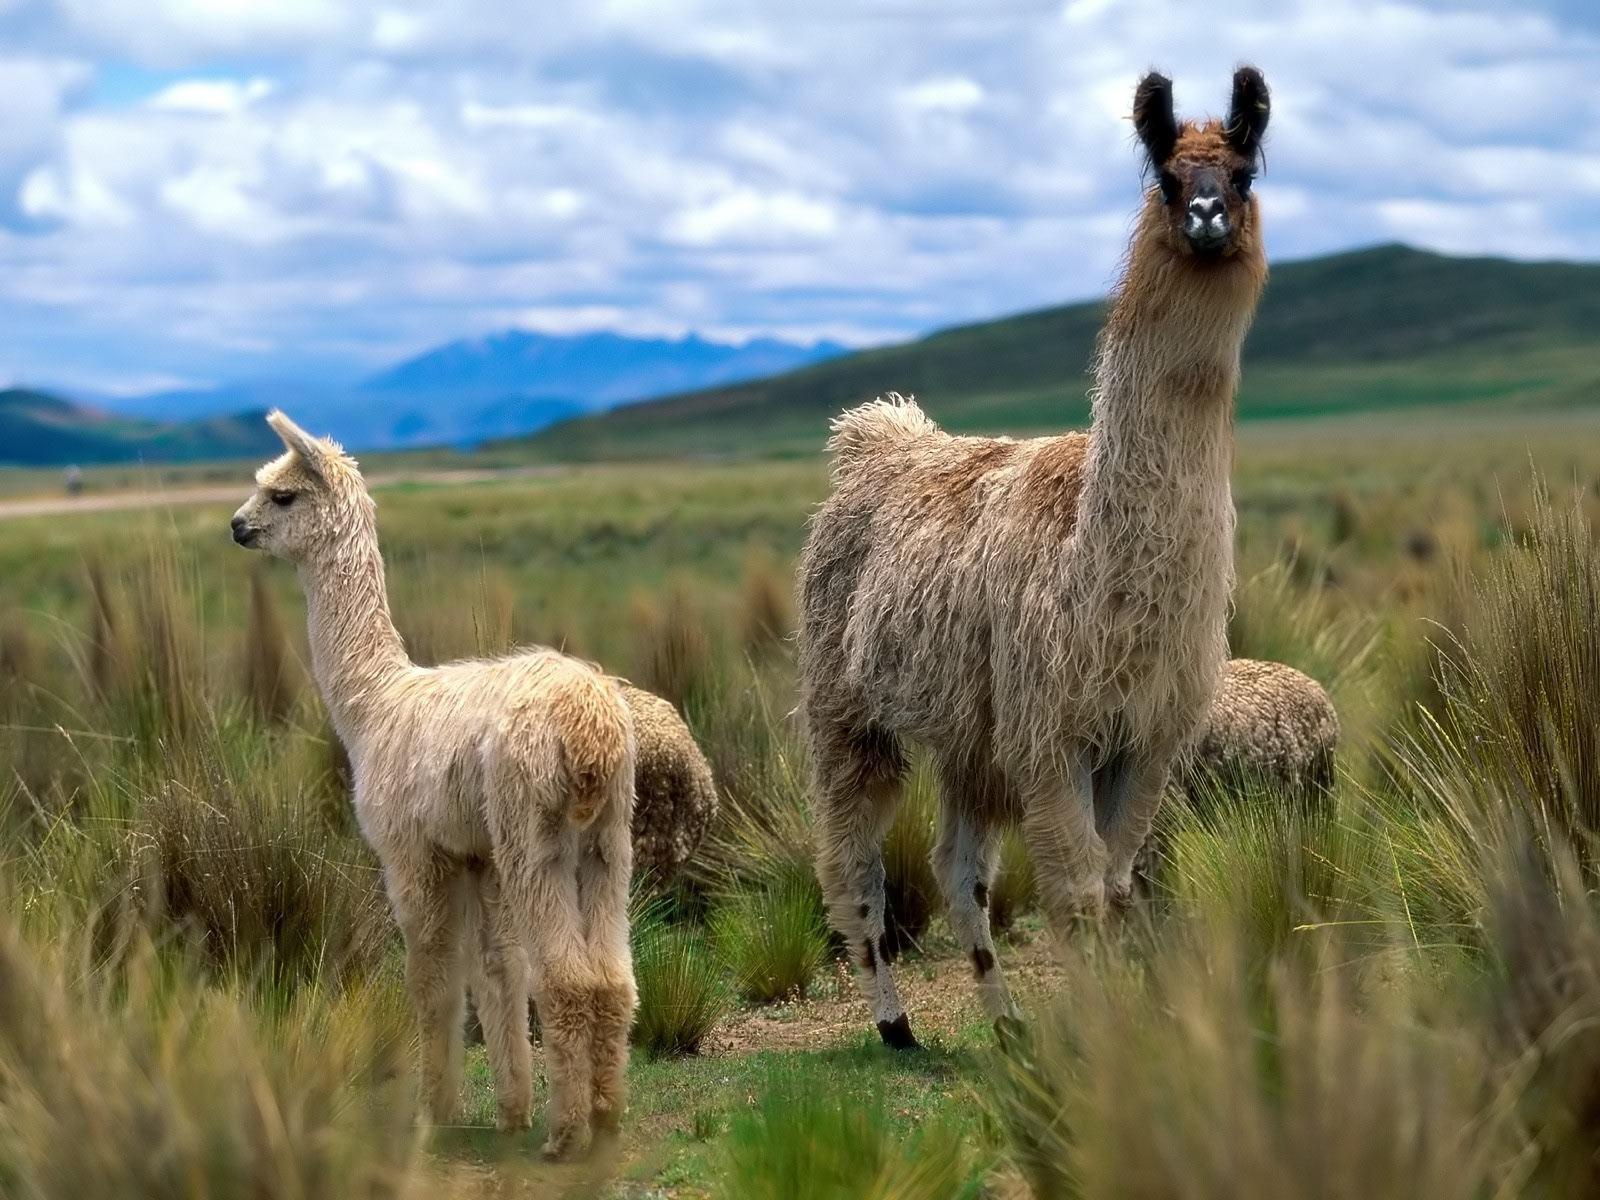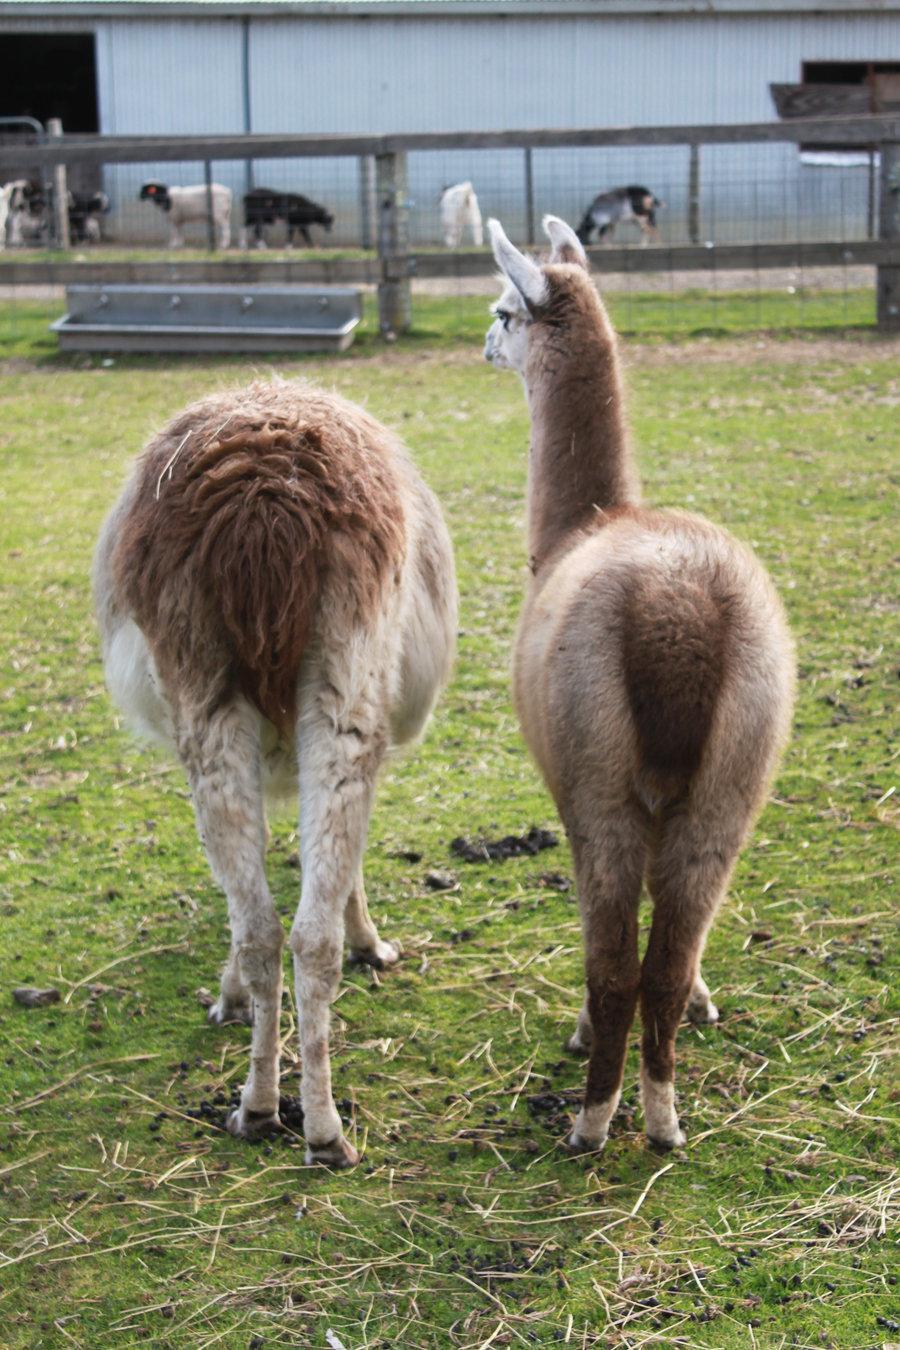The first image is the image on the left, the second image is the image on the right. Analyze the images presented: Is the assertion "All the llamas have leashes." valid? Answer yes or no. No. The first image is the image on the left, the second image is the image on the right. Evaluate the accuracy of this statement regarding the images: "A woman in a tank top is standing to the right of a llama and holding a blue rope attached to its harness.". Is it true? Answer yes or no. No. 